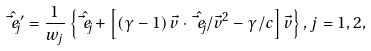Convert formula to latex. <formula><loc_0><loc_0><loc_500><loc_500>\hat { \vec { e } _ { j } } ^ { \prime } = \frac { 1 } { w _ { j } } \left \{ \hat { \vec { e } _ { j } } + \left [ \left ( \gamma - 1 \right ) \vec { v } \cdot \hat { \vec { e } _ { j } } / \vec { v } ^ { 2 } - \gamma / c \right ] \vec { v } \right \} , j = 1 , 2 ,</formula> 